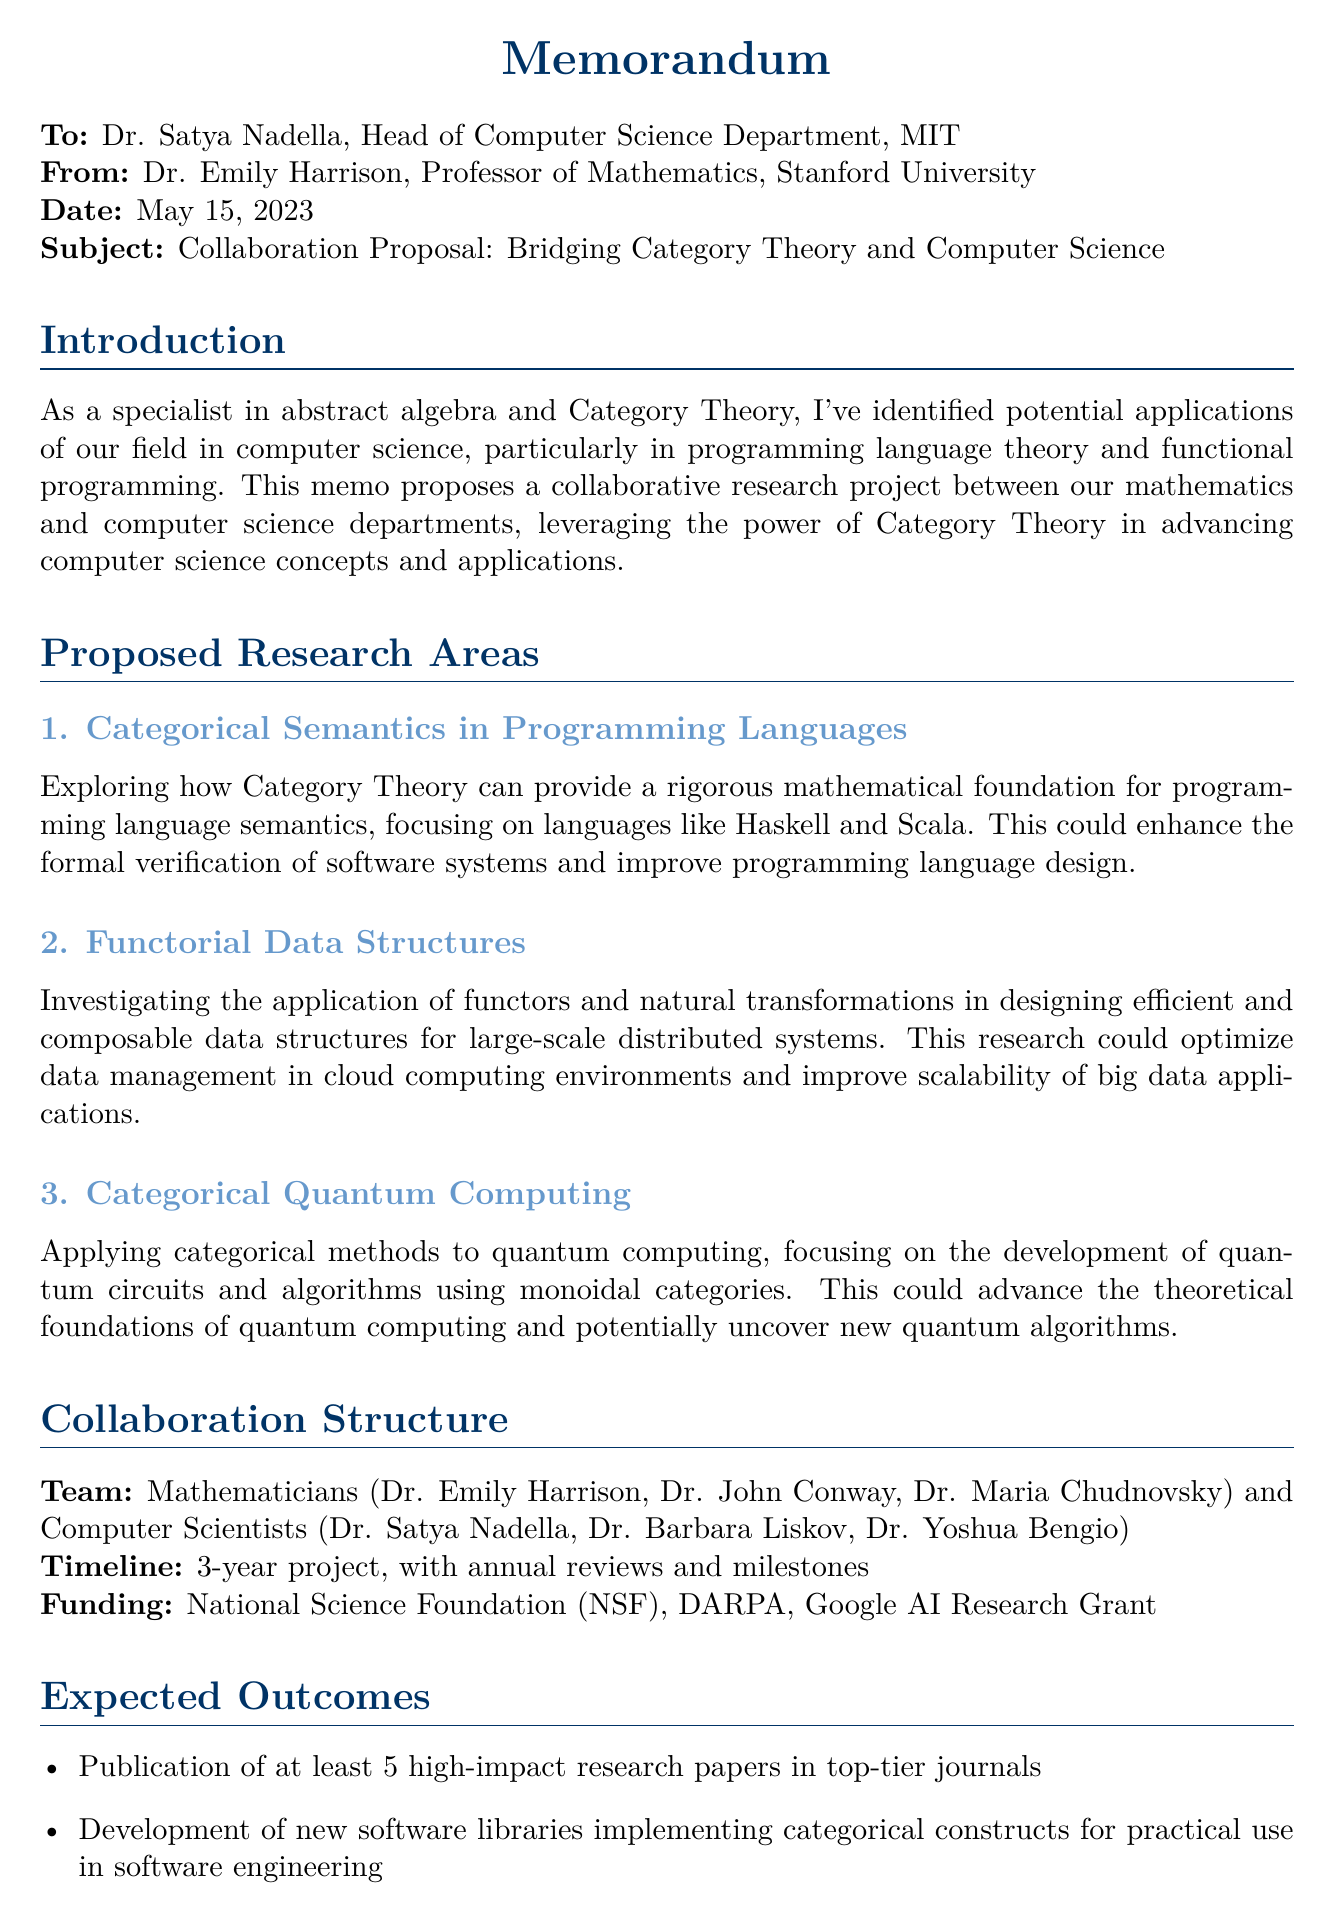What is the subject of the memo? The subject of the memo is stated clearly in the header section of the document.
Answer: Collaboration Proposal: Bridging Category Theory and Computer Science Who is the author of the memo? The author is mentioned in the "from" section of the document.
Answer: Dr. Emily Harrison What is the proposed duration of the project? The duration of the project is specified in the collaboration structure section.
Answer: 3-year project Name one source of funding mentioned in the document. The funding sources are listed in the collaboration structure section of the memo.
Answer: National Science Foundation (NSF) What is one expected outcome of the collaboration? Expected outcomes are outlined in the relevant section of the memo.
Answer: Publication of at least 5 high-impact research papers in top-tier journals How many mathematicians are part of the proposed team? The number of mathematicians can be found in the team composition section.
Answer: 3 What specific area does "Functorial Data Structures" focus on? The description of this proposed research area provides insight into its focus.
Answer: Designing efficient and composable data structures for large-scale distributed systems What action does the author propose to pursue next? The conclusion section highlights the next steps as indicated by the author.
Answer: Schedule a meeting next month 